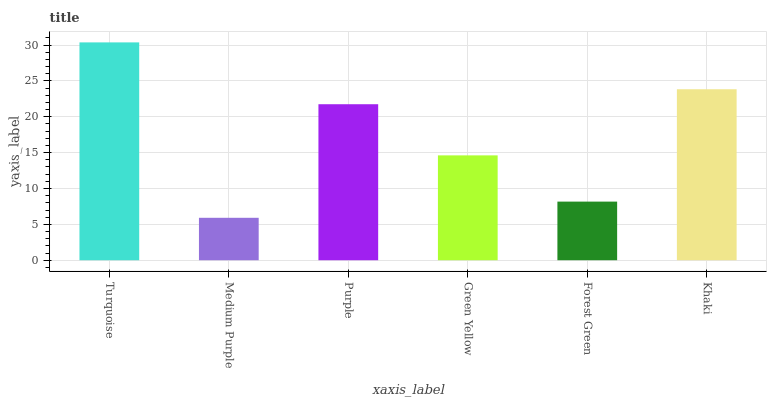Is Purple the minimum?
Answer yes or no. No. Is Purple the maximum?
Answer yes or no. No. Is Purple greater than Medium Purple?
Answer yes or no. Yes. Is Medium Purple less than Purple?
Answer yes or no. Yes. Is Medium Purple greater than Purple?
Answer yes or no. No. Is Purple less than Medium Purple?
Answer yes or no. No. Is Purple the high median?
Answer yes or no. Yes. Is Green Yellow the low median?
Answer yes or no. Yes. Is Medium Purple the high median?
Answer yes or no. No. Is Purple the low median?
Answer yes or no. No. 